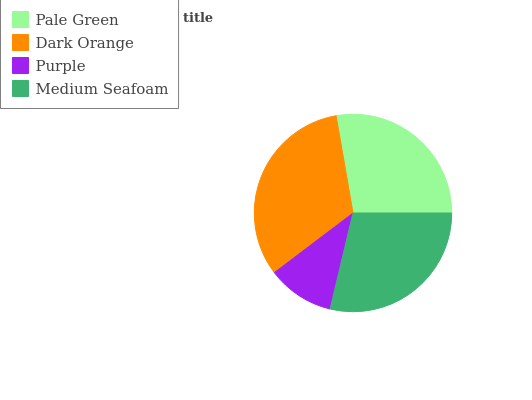Is Purple the minimum?
Answer yes or no. Yes. Is Dark Orange the maximum?
Answer yes or no. Yes. Is Dark Orange the minimum?
Answer yes or no. No. Is Purple the maximum?
Answer yes or no. No. Is Dark Orange greater than Purple?
Answer yes or no. Yes. Is Purple less than Dark Orange?
Answer yes or no. Yes. Is Purple greater than Dark Orange?
Answer yes or no. No. Is Dark Orange less than Purple?
Answer yes or no. No. Is Medium Seafoam the high median?
Answer yes or no. Yes. Is Pale Green the low median?
Answer yes or no. Yes. Is Dark Orange the high median?
Answer yes or no. No. Is Dark Orange the low median?
Answer yes or no. No. 